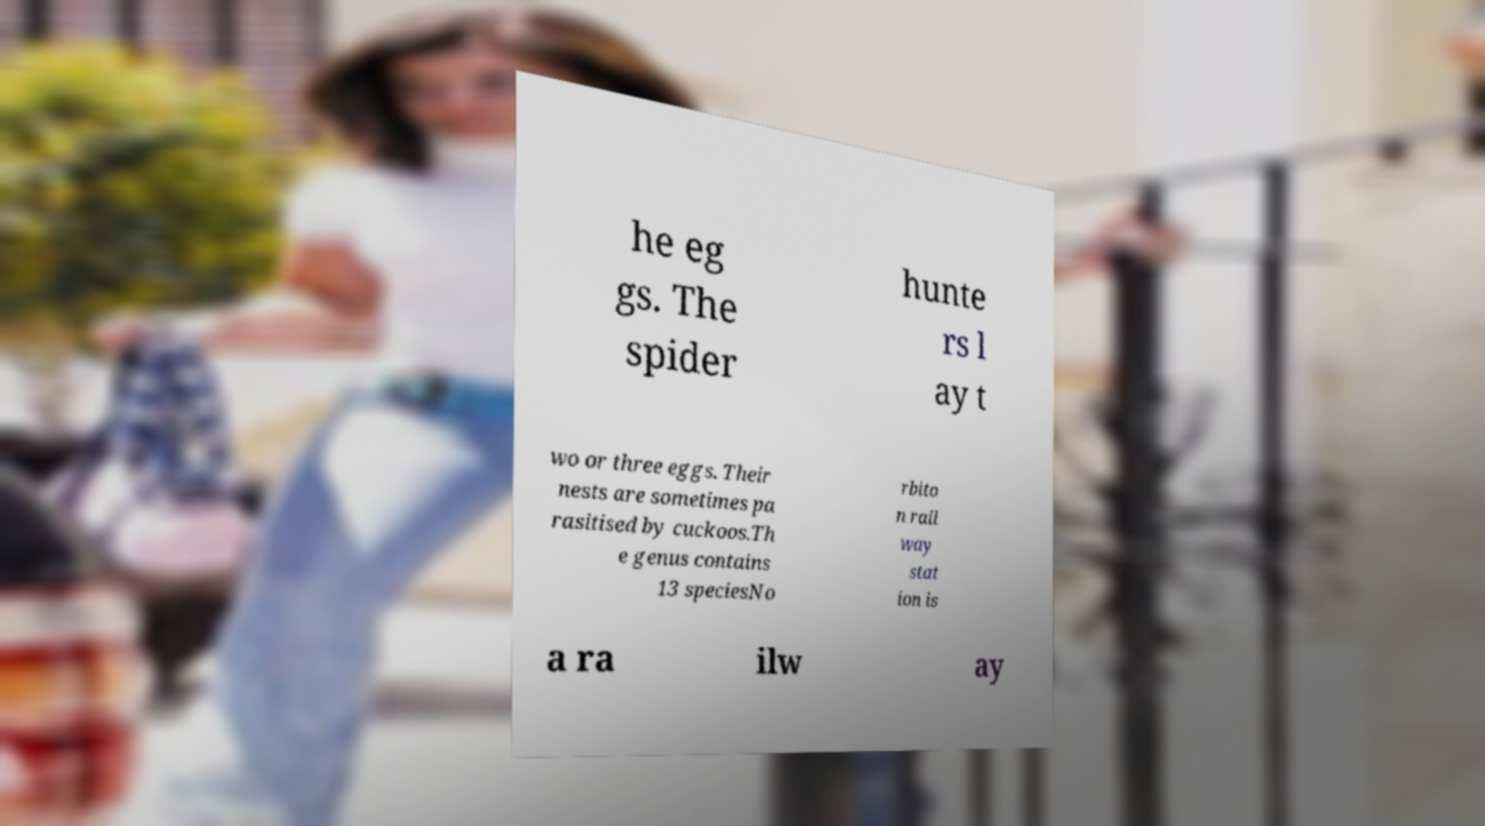Can you accurately transcribe the text from the provided image for me? he eg gs. The spider hunte rs l ay t wo or three eggs. Their nests are sometimes pa rasitised by cuckoos.Th e genus contains 13 speciesNo rbito n rail way stat ion is a ra ilw ay 